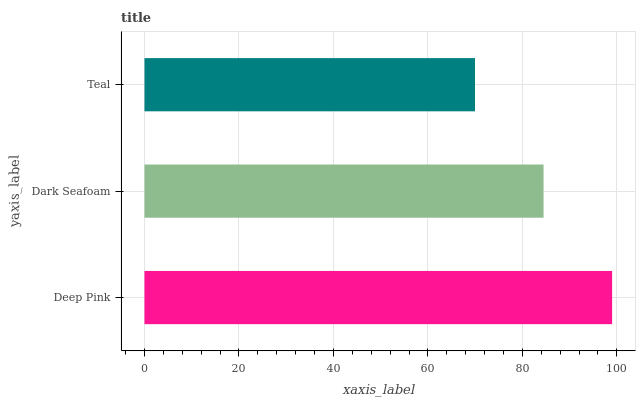Is Teal the minimum?
Answer yes or no. Yes. Is Deep Pink the maximum?
Answer yes or no. Yes. Is Dark Seafoam the minimum?
Answer yes or no. No. Is Dark Seafoam the maximum?
Answer yes or no. No. Is Deep Pink greater than Dark Seafoam?
Answer yes or no. Yes. Is Dark Seafoam less than Deep Pink?
Answer yes or no. Yes. Is Dark Seafoam greater than Deep Pink?
Answer yes or no. No. Is Deep Pink less than Dark Seafoam?
Answer yes or no. No. Is Dark Seafoam the high median?
Answer yes or no. Yes. Is Dark Seafoam the low median?
Answer yes or no. Yes. Is Deep Pink the high median?
Answer yes or no. No. Is Teal the low median?
Answer yes or no. No. 